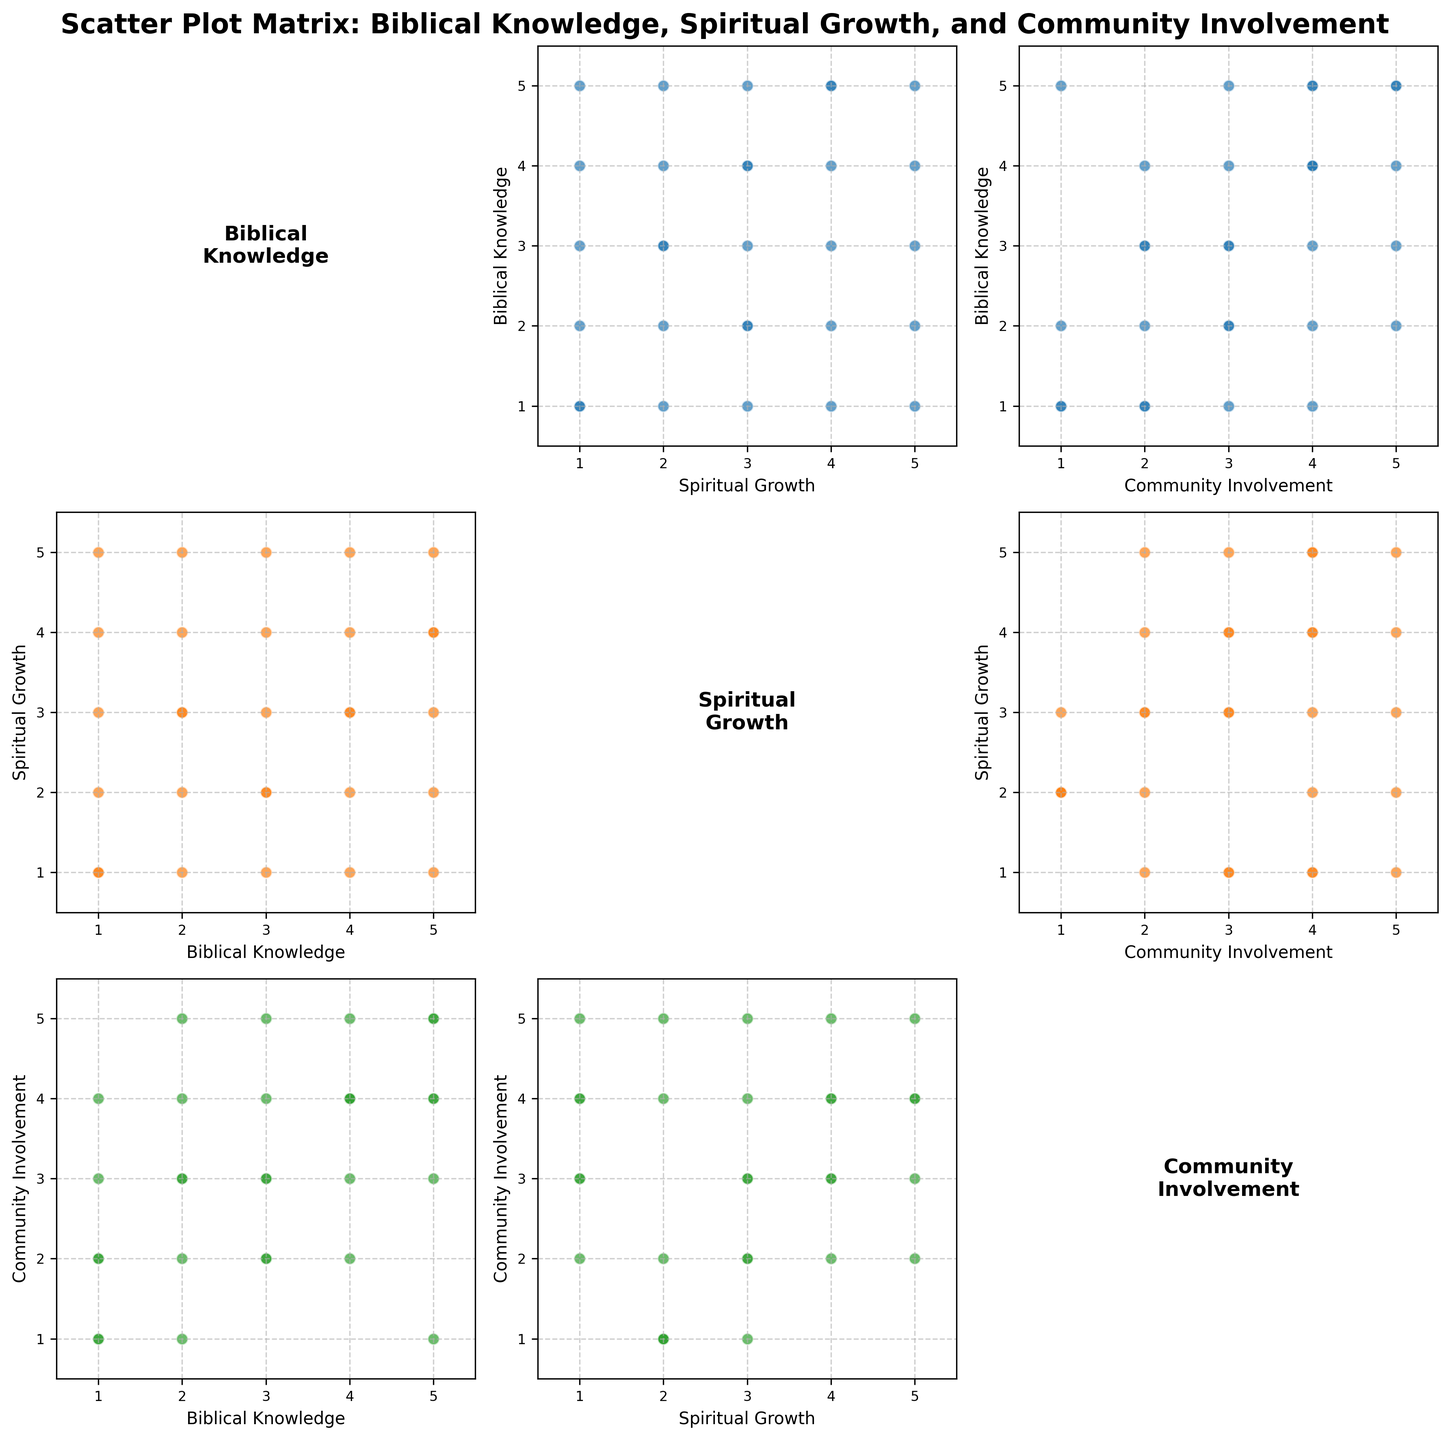What is the relationship between Biblical Knowledge and Community Involvement? To identify the relationship, look at the scatter plot matrix where these two variables intersect. Observe if there's a trend or pattern, such as points aligning along a line, which indicates a correlation.
Answer: Positive correlation Which variable shows the strongest positive correlation with Spiritual Growth? Examine the scatter plots where 'Spiritual Growth' is on one axis. Check for the plot with the steepest diagonal line, symbolizing the most significant positive correlation. The comparison involves the plots with 'Biblical Knowledge' and 'Community Involvement'.
Answer: Biblical Knowledge How does Community Involvement relate visually to Spiritual Growth in the scatter plot matrix (e.g., linear, scattered, clustered)? Look at the plot where 'Community Involvement' is on the x-axis, and 'Spiritual Growth' is on the y-axis. Observe the distribution pattern of the points. Are they forming any specific shape like a line or are they spread randomly?
Answer: Scattered Which quadrant (upper, lower, left, right) shows the highest density of points in Biblical Knowledge vs. Community Involvement plot? Observe the scatter plot intersections for these variables. Identify where most of the points are clustered within the plot's quadrants.
Answer: Top-right Are there outliers in the plot comparing Spiritual Growth and Biblical Knowledge? If so, what are they? Outliers are points that fall far from the other points. In the plot with 'Spiritual Growth' vs 'Biblical Knowledge', scan for any points isolated from the general grouping of points.
Answer: Yes, (1, 2) What is the average value of data points in the plot of Biblical Knowledge vs. Community Involvement? Calculate the average by summing up all the x-values (Biblical Knowledge) and y-values (Community Involvement), then divide by the number of points. The calculation involves (sum of x-values/number of points, sum of y-values/number of points)
Answer: (3, 3) Which scatter plot pair shows a mix of high and low points across both axes without a clear correlation? Evaluate each pair of scatter plots to see if any display points that do not follow a significant upward or downward trend but remain dispersed.
Answer: Community Involvement vs. Biblical Knowledge In the scatter plot of Biblical Knowledge vs. Spiritual Growth, which knowledge levels (1-5) show the highest clustering? Inspect the levels of 'Biblical Knowledge' on the x-axis and identify at which level the points appear most densely packed on the y-axis (Spiritual Growth).
Answer: Levels 3 and 4 Do higher levels of Community Involvement generally correspond to higher values of Spiritual Growth? Analyze the plot where 'Community Involvement' is on the x-axis and 'Spiritual Growth' on the y-axis, look for an upward trend indicating higher values on one correspond to increases in the other.
Answer: Somewhat Which variables show the least amount of covariance visually? Assess the scatter plots for pairs of variables lacking discernible trends. Covariance is minimal where variables don't exhibit a consistent relationship in their data points.
Answer: Community Involvement and Spiritual Growth 